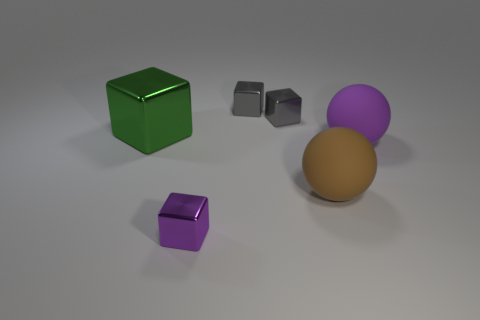If the larger purple sphere moved towards the green cube, which object would it encounter first? If the larger purple sphere were to move toward the green cube, it would first come within closer proximity to the brown sphere, as they are initially the closest objects to one another. The brown sphere would act as an intermediary between the purple sphere and the green cube based on their current arrangement in the image. 